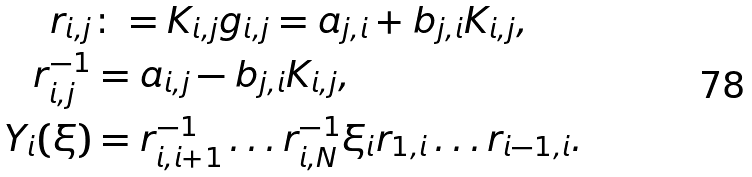<formula> <loc_0><loc_0><loc_500><loc_500>r _ { i , j } & \colon = K _ { i , j } g _ { i , j } = a _ { j , i } + b _ { j , i } K _ { i , j } , \\ r _ { i , j } ^ { - 1 } & = a _ { i , j } - b _ { j , i } K _ { i , j } , \\ Y _ { i } ( \xi ) & = r _ { i , i + 1 } ^ { - 1 } \dots r _ { i , N } ^ { - 1 } \xi _ { i } r _ { 1 , i } \dots r _ { i - 1 , i } .</formula> 